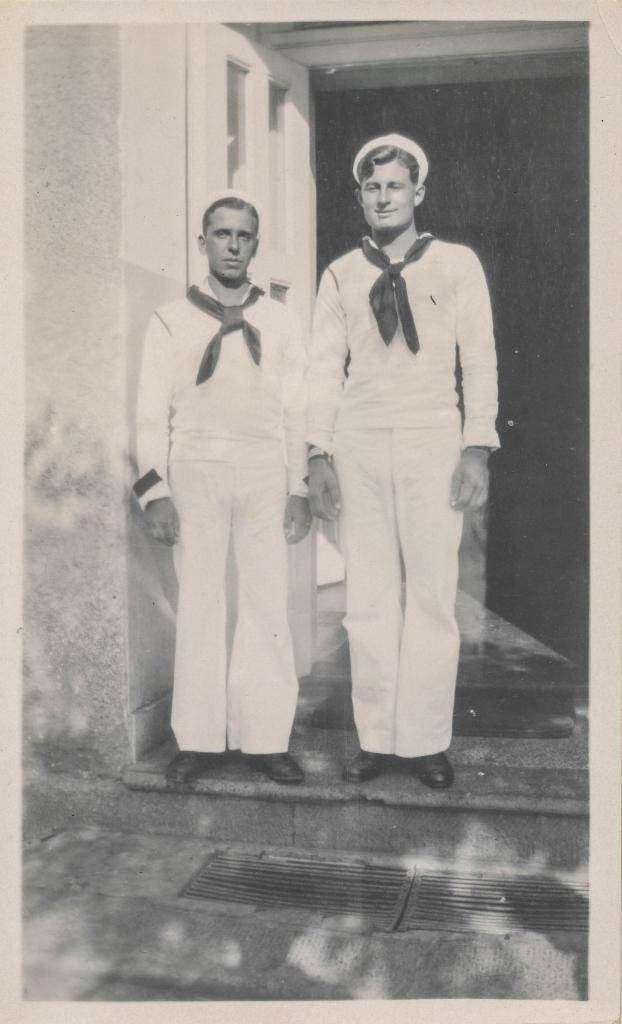What is the color scheme of the image? The image is black and white. How many people are in the image? There are two men in the image. What are the men wearing on their heads? The men are wearing caps. What type of footwear are the men wearing? The men are wearing shoes. Where are the men standing in the image? The men are standing on the floor. What can be seen in the image related to cooking? There are grills in the image. What architectural features are present in the image? There is a door and a wall in the image. How would you describe the lighting in the image? The background of the image is dark. What time of day is it in the image, considering the afternoon light? The image is black and white, so it is not possible to determine the time of day based on the lighting. Can you tell me how many drawers are visible in the image? There are no drawers present in the image. 